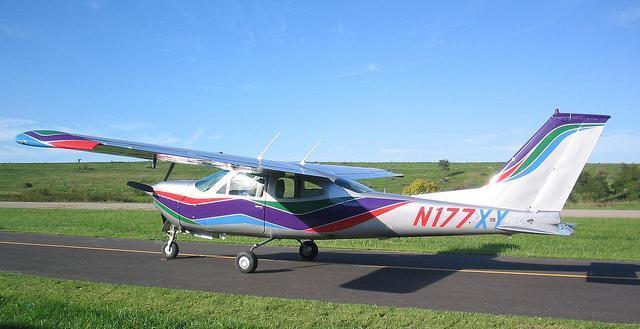How many people are wearing black shirt?
Give a very brief answer. 0. 